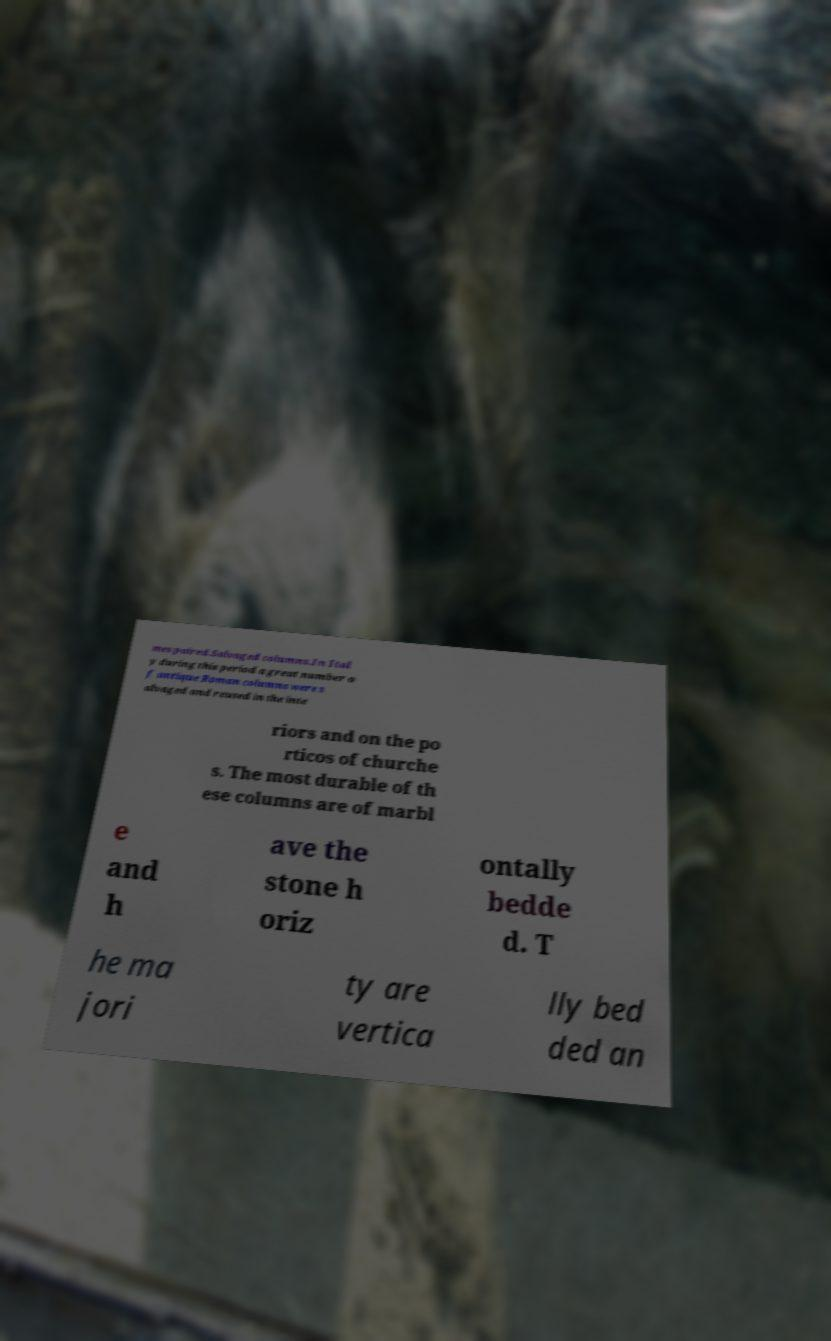Could you assist in decoding the text presented in this image and type it out clearly? mes paired.Salvaged columns.In Ital y during this period a great number o f antique Roman columns were s alvaged and reused in the inte riors and on the po rticos of churche s. The most durable of th ese columns are of marbl e and h ave the stone h oriz ontally bedde d. T he ma jori ty are vertica lly bed ded an 